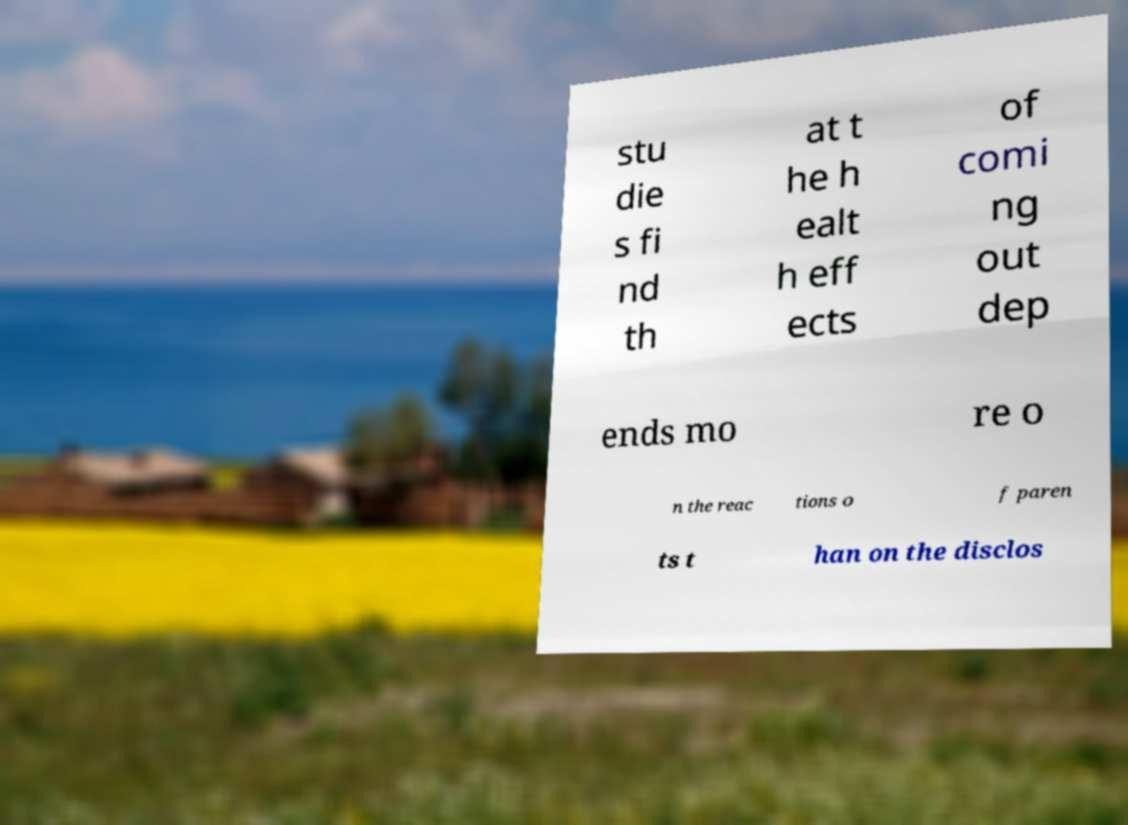I need the written content from this picture converted into text. Can you do that? stu die s fi nd th at t he h ealt h eff ects of comi ng out dep ends mo re o n the reac tions o f paren ts t han on the disclos 